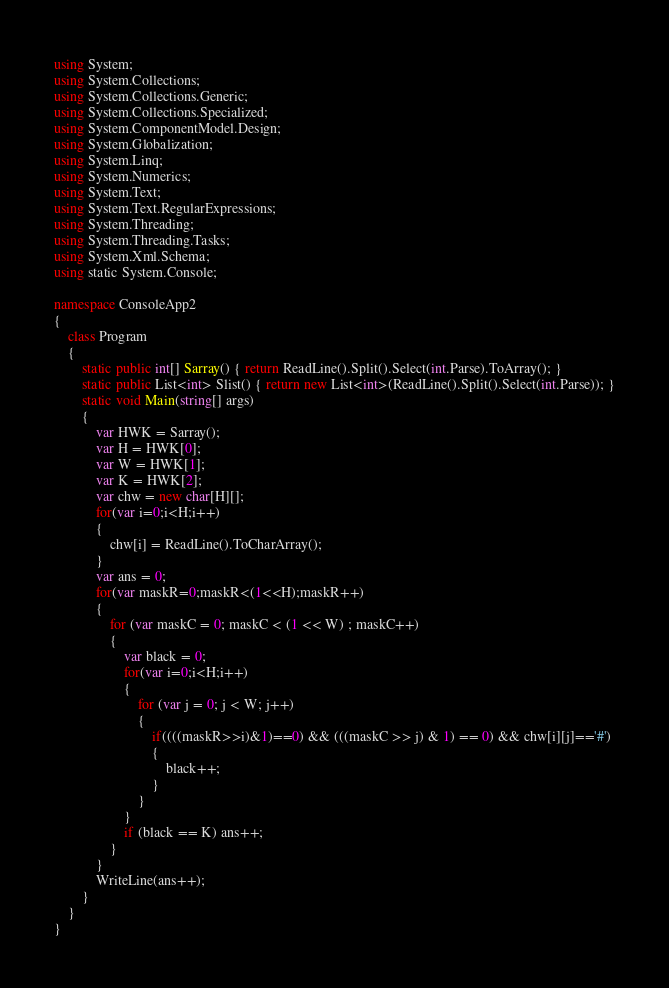Convert code to text. <code><loc_0><loc_0><loc_500><loc_500><_C#_>using System;
using System.Collections;
using System.Collections.Generic;
using System.Collections.Specialized;
using System.ComponentModel.Design;
using System.Globalization;
using System.Linq;
using System.Numerics;
using System.Text;
using System.Text.RegularExpressions;
using System.Threading;
using System.Threading.Tasks;
using System.Xml.Schema;
using static System.Console;

namespace ConsoleApp2
{
    class Program
    {
        static public int[] Sarray() { return ReadLine().Split().Select(int.Parse).ToArray(); }
        static public List<int> Slist() { return new List<int>(ReadLine().Split().Select(int.Parse)); }
        static void Main(string[] args)
        {
            var HWK = Sarray();
            var H = HWK[0];
            var W = HWK[1];
            var K = HWK[2];
            var chw = new char[H][];
            for(var i=0;i<H;i++)
            {
                chw[i] = ReadLine().ToCharArray();
            }
            var ans = 0;
            for(var maskR=0;maskR<(1<<H);maskR++)
            {
                for (var maskC = 0; maskC < (1 << W) ; maskC++)
                {
                    var black = 0;
                    for(var i=0;i<H;i++)
                    {
                        for (var j = 0; j < W; j++)
                        {
                            if((((maskR>>i)&1)==0) && (((maskC >> j) & 1) == 0) && chw[i][j]=='#')
                            {
                                black++;
                            }
                        }
                    }
                    if (black == K) ans++;
                }
            }
            WriteLine(ans++);
        }
    }
}</code> 